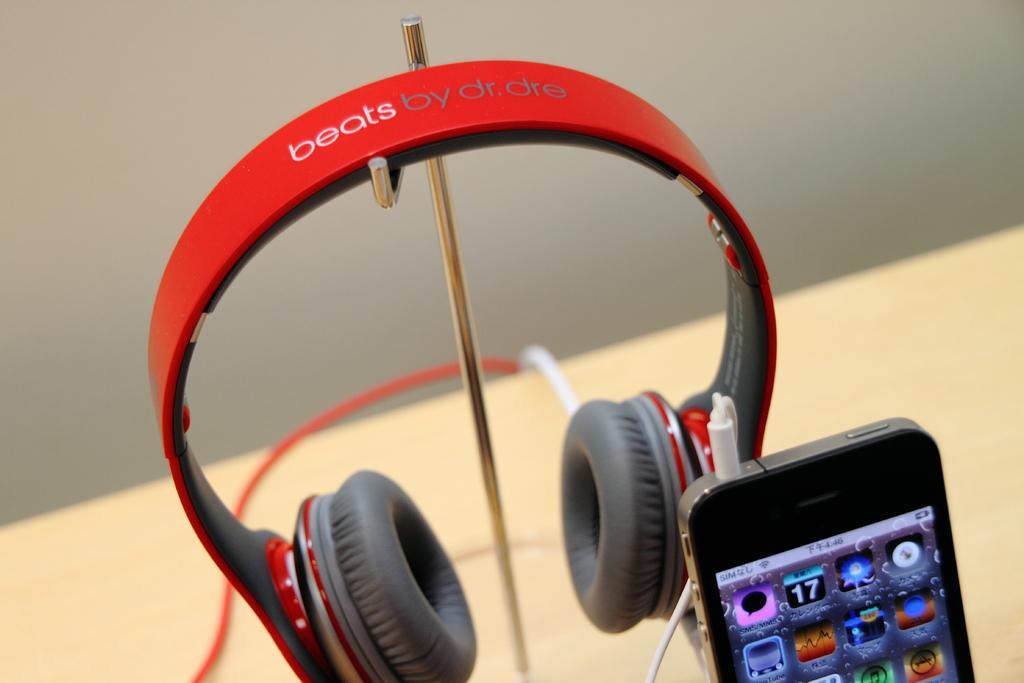Could you give a brief overview of what you see in this image? In this image, we can see headphones on the stand. There is a phone in the bottom right of the image. In the background, image is blurred. 